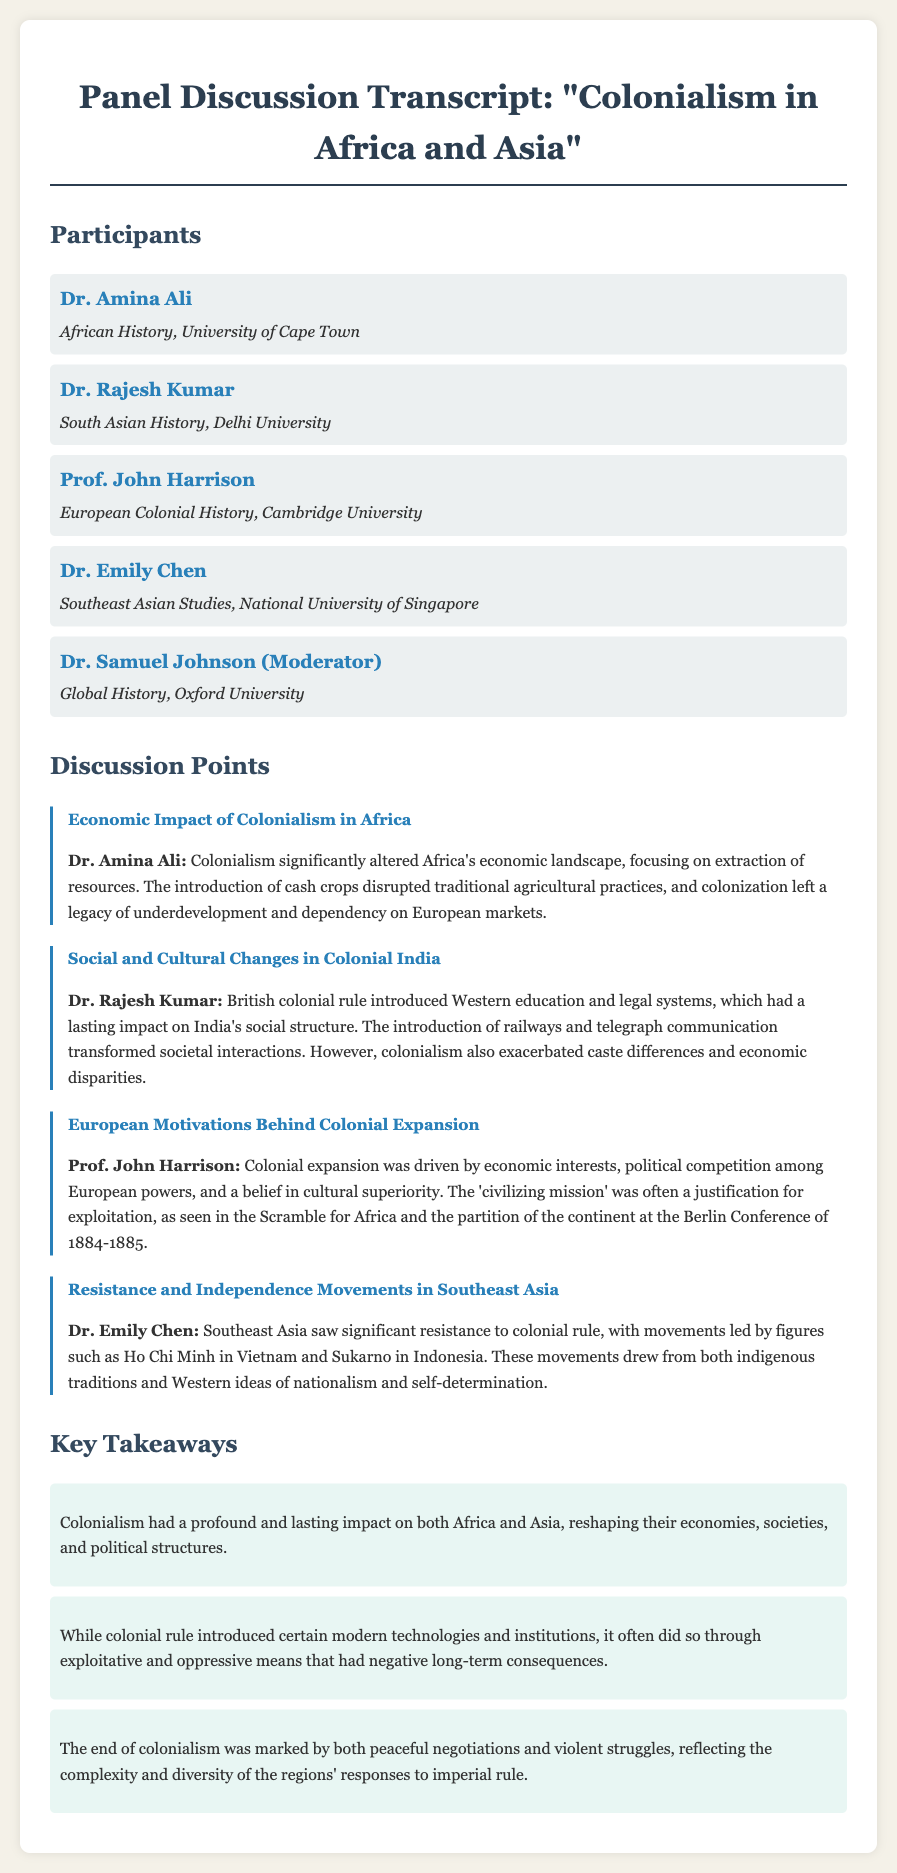What is the title of the panel discussion? The title is the main heading that represents the subject of the document.
Answer: "Colonialism in Africa and Asia" Who is affiliated with the University of Cape Town? The name associated with the University of Cape Town is specifically noted as one of the participants in the document.
Answer: Dr. Amina Ali What economic impact did Dr. Amina Ali mention? The specific impact noted discusses alterations in Africa's economic landscape due to colonialism, focusing on resource extraction, which is key to understanding the discussion points.
Answer: Extraction of resources Who discussed the social and cultural changes in Colonial India? The participant’s name that specifically addresses these changes is highlighted in the document.
Answer: Dr. Rajesh Kumar What was one reason behind European colonial expansion according to Prof. John Harrison? This focuses on the motivations discussed in the panel, highlighting economic interests as one of the main factors outlined during the discussion.
Answer: Economic interests Name a figure associated with resistance movements in Southeast Asia mentioned by Dr. Emily Chen. The participant refers to important individuals leading the resistance, which points to the significant historical context of the discussion.
Answer: Ho Chi Minh What was a key takeaway regarding the impact of colonialism? This summarizes a critical insight that reflects the overall effects of colonialism presented in a concise manner at the end of the transcript.
Answer: Profound and lasting impact How did the end of colonialism vary according to the key takeaways? This addresses the complexity of the responses to colonial rule as noted in the conclusions drawn in the discussion.
Answer: Peaceful negotiations and violent struggles 